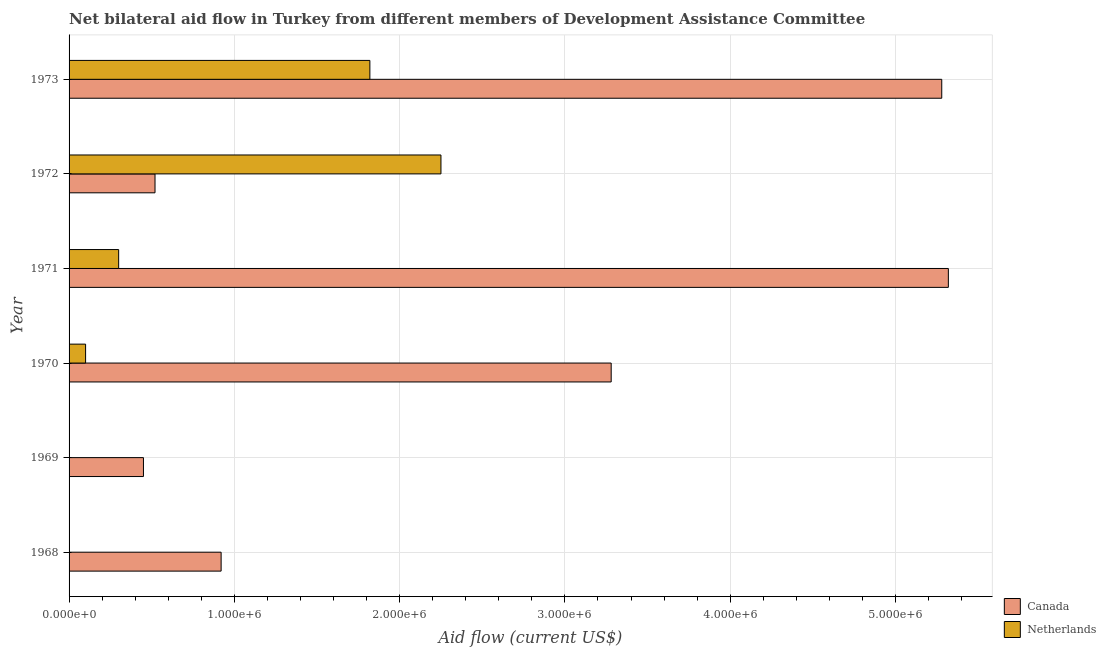How many different coloured bars are there?
Provide a succinct answer. 2. In how many cases, is the number of bars for a given year not equal to the number of legend labels?
Provide a succinct answer. 2. What is the amount of aid given by netherlands in 1972?
Provide a succinct answer. 2.25e+06. Across all years, what is the maximum amount of aid given by netherlands?
Make the answer very short. 2.25e+06. Across all years, what is the minimum amount of aid given by canada?
Make the answer very short. 4.50e+05. In which year was the amount of aid given by canada maximum?
Provide a succinct answer. 1971. What is the total amount of aid given by netherlands in the graph?
Offer a very short reply. 4.47e+06. What is the difference between the amount of aid given by canada in 1971 and that in 1973?
Offer a very short reply. 4.00e+04. What is the difference between the amount of aid given by canada in 1970 and the amount of aid given by netherlands in 1973?
Keep it short and to the point. 1.46e+06. What is the average amount of aid given by canada per year?
Offer a very short reply. 2.63e+06. In the year 1972, what is the difference between the amount of aid given by netherlands and amount of aid given by canada?
Give a very brief answer. 1.73e+06. In how many years, is the amount of aid given by canada greater than 1600000 US$?
Offer a very short reply. 3. What is the ratio of the amount of aid given by canada in 1968 to that in 1971?
Provide a short and direct response. 0.17. What is the difference between the highest and the second highest amount of aid given by netherlands?
Provide a short and direct response. 4.30e+05. What is the difference between the highest and the lowest amount of aid given by canada?
Your answer should be compact. 4.87e+06. Is the sum of the amount of aid given by canada in 1971 and 1973 greater than the maximum amount of aid given by netherlands across all years?
Give a very brief answer. Yes. How many bars are there?
Provide a succinct answer. 10. Are all the bars in the graph horizontal?
Your answer should be compact. Yes. What is the difference between two consecutive major ticks on the X-axis?
Give a very brief answer. 1.00e+06. Are the values on the major ticks of X-axis written in scientific E-notation?
Offer a terse response. Yes. How many legend labels are there?
Provide a succinct answer. 2. What is the title of the graph?
Provide a short and direct response. Net bilateral aid flow in Turkey from different members of Development Assistance Committee. What is the label or title of the Y-axis?
Keep it short and to the point. Year. What is the Aid flow (current US$) in Canada in 1968?
Offer a terse response. 9.20e+05. What is the Aid flow (current US$) of Canada in 1969?
Ensure brevity in your answer.  4.50e+05. What is the Aid flow (current US$) in Netherlands in 1969?
Offer a terse response. 0. What is the Aid flow (current US$) of Canada in 1970?
Keep it short and to the point. 3.28e+06. What is the Aid flow (current US$) of Netherlands in 1970?
Your response must be concise. 1.00e+05. What is the Aid flow (current US$) of Canada in 1971?
Keep it short and to the point. 5.32e+06. What is the Aid flow (current US$) in Netherlands in 1971?
Provide a short and direct response. 3.00e+05. What is the Aid flow (current US$) of Canada in 1972?
Make the answer very short. 5.20e+05. What is the Aid flow (current US$) of Netherlands in 1972?
Provide a succinct answer. 2.25e+06. What is the Aid flow (current US$) of Canada in 1973?
Your answer should be very brief. 5.28e+06. What is the Aid flow (current US$) of Netherlands in 1973?
Give a very brief answer. 1.82e+06. Across all years, what is the maximum Aid flow (current US$) of Canada?
Offer a very short reply. 5.32e+06. Across all years, what is the maximum Aid flow (current US$) in Netherlands?
Keep it short and to the point. 2.25e+06. Across all years, what is the minimum Aid flow (current US$) in Netherlands?
Make the answer very short. 0. What is the total Aid flow (current US$) in Canada in the graph?
Your answer should be compact. 1.58e+07. What is the total Aid flow (current US$) of Netherlands in the graph?
Offer a terse response. 4.47e+06. What is the difference between the Aid flow (current US$) in Canada in 1968 and that in 1969?
Offer a terse response. 4.70e+05. What is the difference between the Aid flow (current US$) in Canada in 1968 and that in 1970?
Ensure brevity in your answer.  -2.36e+06. What is the difference between the Aid flow (current US$) in Canada in 1968 and that in 1971?
Your answer should be very brief. -4.40e+06. What is the difference between the Aid flow (current US$) of Canada in 1968 and that in 1973?
Your response must be concise. -4.36e+06. What is the difference between the Aid flow (current US$) of Canada in 1969 and that in 1970?
Keep it short and to the point. -2.83e+06. What is the difference between the Aid flow (current US$) of Canada in 1969 and that in 1971?
Offer a terse response. -4.87e+06. What is the difference between the Aid flow (current US$) of Canada in 1969 and that in 1973?
Provide a succinct answer. -4.83e+06. What is the difference between the Aid flow (current US$) in Canada in 1970 and that in 1971?
Offer a very short reply. -2.04e+06. What is the difference between the Aid flow (current US$) of Canada in 1970 and that in 1972?
Your answer should be compact. 2.76e+06. What is the difference between the Aid flow (current US$) in Netherlands in 1970 and that in 1972?
Keep it short and to the point. -2.15e+06. What is the difference between the Aid flow (current US$) in Netherlands in 1970 and that in 1973?
Make the answer very short. -1.72e+06. What is the difference between the Aid flow (current US$) of Canada in 1971 and that in 1972?
Ensure brevity in your answer.  4.80e+06. What is the difference between the Aid flow (current US$) in Netherlands in 1971 and that in 1972?
Provide a succinct answer. -1.95e+06. What is the difference between the Aid flow (current US$) in Netherlands in 1971 and that in 1973?
Offer a very short reply. -1.52e+06. What is the difference between the Aid flow (current US$) of Canada in 1972 and that in 1973?
Make the answer very short. -4.76e+06. What is the difference between the Aid flow (current US$) of Netherlands in 1972 and that in 1973?
Your answer should be very brief. 4.30e+05. What is the difference between the Aid flow (current US$) in Canada in 1968 and the Aid flow (current US$) in Netherlands in 1970?
Keep it short and to the point. 8.20e+05. What is the difference between the Aid flow (current US$) of Canada in 1968 and the Aid flow (current US$) of Netherlands in 1971?
Offer a terse response. 6.20e+05. What is the difference between the Aid flow (current US$) in Canada in 1968 and the Aid flow (current US$) in Netherlands in 1972?
Provide a short and direct response. -1.33e+06. What is the difference between the Aid flow (current US$) in Canada in 1968 and the Aid flow (current US$) in Netherlands in 1973?
Provide a short and direct response. -9.00e+05. What is the difference between the Aid flow (current US$) in Canada in 1969 and the Aid flow (current US$) in Netherlands in 1972?
Your response must be concise. -1.80e+06. What is the difference between the Aid flow (current US$) in Canada in 1969 and the Aid flow (current US$) in Netherlands in 1973?
Provide a short and direct response. -1.37e+06. What is the difference between the Aid flow (current US$) of Canada in 1970 and the Aid flow (current US$) of Netherlands in 1971?
Offer a very short reply. 2.98e+06. What is the difference between the Aid flow (current US$) of Canada in 1970 and the Aid flow (current US$) of Netherlands in 1972?
Offer a terse response. 1.03e+06. What is the difference between the Aid flow (current US$) in Canada in 1970 and the Aid flow (current US$) in Netherlands in 1973?
Offer a very short reply. 1.46e+06. What is the difference between the Aid flow (current US$) in Canada in 1971 and the Aid flow (current US$) in Netherlands in 1972?
Your response must be concise. 3.07e+06. What is the difference between the Aid flow (current US$) of Canada in 1971 and the Aid flow (current US$) of Netherlands in 1973?
Ensure brevity in your answer.  3.50e+06. What is the difference between the Aid flow (current US$) in Canada in 1972 and the Aid flow (current US$) in Netherlands in 1973?
Your response must be concise. -1.30e+06. What is the average Aid flow (current US$) of Canada per year?
Ensure brevity in your answer.  2.63e+06. What is the average Aid flow (current US$) of Netherlands per year?
Make the answer very short. 7.45e+05. In the year 1970, what is the difference between the Aid flow (current US$) of Canada and Aid flow (current US$) of Netherlands?
Your answer should be very brief. 3.18e+06. In the year 1971, what is the difference between the Aid flow (current US$) of Canada and Aid flow (current US$) of Netherlands?
Ensure brevity in your answer.  5.02e+06. In the year 1972, what is the difference between the Aid flow (current US$) of Canada and Aid flow (current US$) of Netherlands?
Provide a short and direct response. -1.73e+06. In the year 1973, what is the difference between the Aid flow (current US$) of Canada and Aid flow (current US$) of Netherlands?
Offer a very short reply. 3.46e+06. What is the ratio of the Aid flow (current US$) in Canada in 1968 to that in 1969?
Ensure brevity in your answer.  2.04. What is the ratio of the Aid flow (current US$) of Canada in 1968 to that in 1970?
Offer a very short reply. 0.28. What is the ratio of the Aid flow (current US$) in Canada in 1968 to that in 1971?
Keep it short and to the point. 0.17. What is the ratio of the Aid flow (current US$) of Canada in 1968 to that in 1972?
Offer a terse response. 1.77. What is the ratio of the Aid flow (current US$) of Canada in 1968 to that in 1973?
Make the answer very short. 0.17. What is the ratio of the Aid flow (current US$) in Canada in 1969 to that in 1970?
Give a very brief answer. 0.14. What is the ratio of the Aid flow (current US$) in Canada in 1969 to that in 1971?
Provide a short and direct response. 0.08. What is the ratio of the Aid flow (current US$) of Canada in 1969 to that in 1972?
Offer a very short reply. 0.87. What is the ratio of the Aid flow (current US$) of Canada in 1969 to that in 1973?
Give a very brief answer. 0.09. What is the ratio of the Aid flow (current US$) of Canada in 1970 to that in 1971?
Keep it short and to the point. 0.62. What is the ratio of the Aid flow (current US$) of Canada in 1970 to that in 1972?
Provide a short and direct response. 6.31. What is the ratio of the Aid flow (current US$) in Netherlands in 1970 to that in 1972?
Your answer should be very brief. 0.04. What is the ratio of the Aid flow (current US$) in Canada in 1970 to that in 1973?
Your response must be concise. 0.62. What is the ratio of the Aid flow (current US$) of Netherlands in 1970 to that in 1973?
Your answer should be very brief. 0.05. What is the ratio of the Aid flow (current US$) in Canada in 1971 to that in 1972?
Your answer should be compact. 10.23. What is the ratio of the Aid flow (current US$) in Netherlands in 1971 to that in 1972?
Give a very brief answer. 0.13. What is the ratio of the Aid flow (current US$) in Canada in 1971 to that in 1973?
Keep it short and to the point. 1.01. What is the ratio of the Aid flow (current US$) of Netherlands in 1971 to that in 1973?
Give a very brief answer. 0.16. What is the ratio of the Aid flow (current US$) in Canada in 1972 to that in 1973?
Offer a terse response. 0.1. What is the ratio of the Aid flow (current US$) in Netherlands in 1972 to that in 1973?
Your answer should be compact. 1.24. What is the difference between the highest and the second highest Aid flow (current US$) of Canada?
Provide a succinct answer. 4.00e+04. What is the difference between the highest and the second highest Aid flow (current US$) in Netherlands?
Keep it short and to the point. 4.30e+05. What is the difference between the highest and the lowest Aid flow (current US$) of Canada?
Offer a terse response. 4.87e+06. What is the difference between the highest and the lowest Aid flow (current US$) of Netherlands?
Provide a succinct answer. 2.25e+06. 